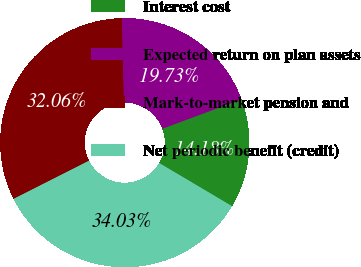Convert chart to OTSL. <chart><loc_0><loc_0><loc_500><loc_500><pie_chart><fcel>Interest cost<fcel>Expected return on plan assets<fcel>Mark-to-market pension and<fcel>Net periodic benefit (credit)<nl><fcel>14.18%<fcel>19.73%<fcel>32.06%<fcel>34.03%<nl></chart> 